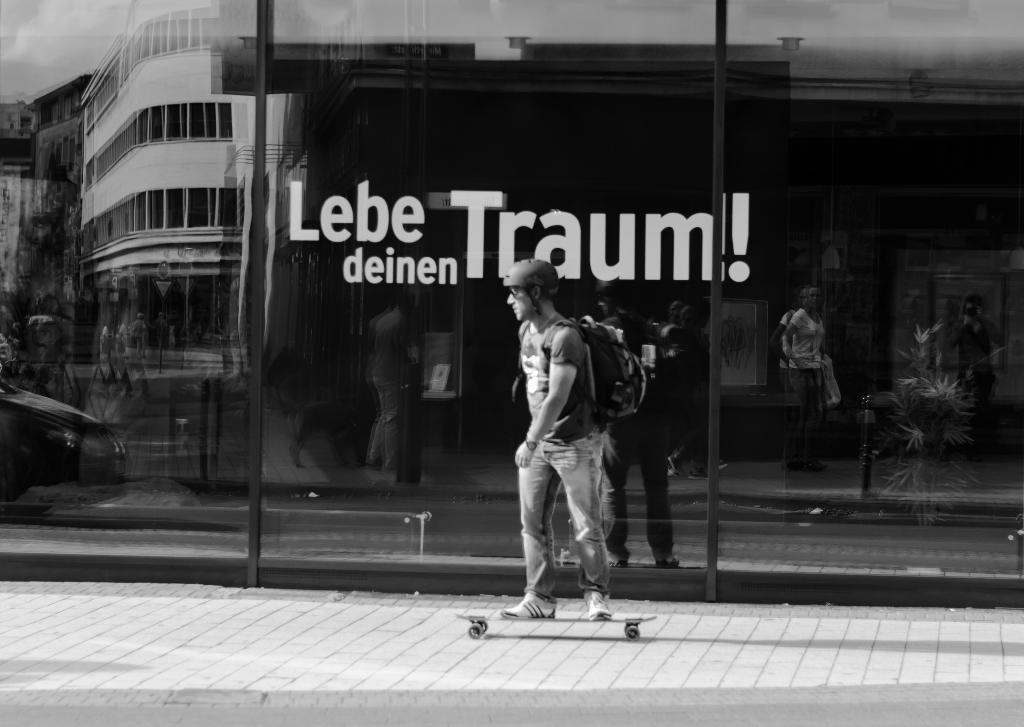Please provide a concise description of this image. In the middle of the image a man is doing skating. Behind him there is a glass wall, on the wall there is a sticker. 